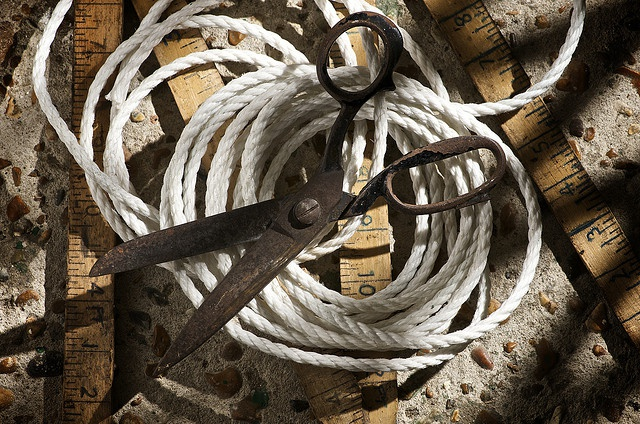Describe the objects in this image and their specific colors. I can see scissors in gray and black tones in this image. 